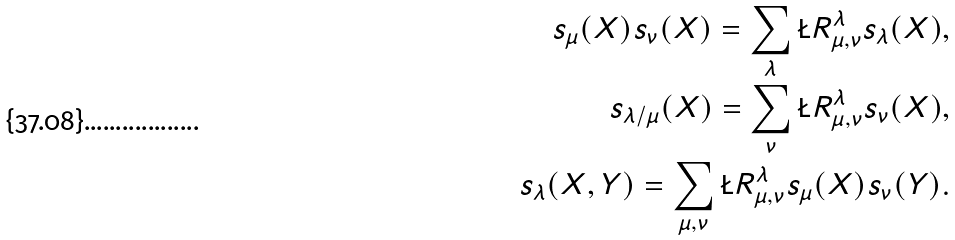Convert formula to latex. <formula><loc_0><loc_0><loc_500><loc_500>s _ { \mu } ( X ) s _ { \nu } ( X ) = \sum _ { \lambda } \L R ^ { \lambda } _ { \mu , \nu } s _ { \lambda } ( X ) , \\ s _ { \lambda / \mu } ( X ) = \sum _ { \nu } \L R ^ { \lambda } _ { \mu , \nu } s _ { \nu } ( X ) , \\ s _ { \lambda } ( X , Y ) = \sum _ { \mu , \nu } \L R ^ { \lambda } _ { \mu , \nu } s _ { \mu } ( X ) s _ { \nu } ( Y ) .</formula> 